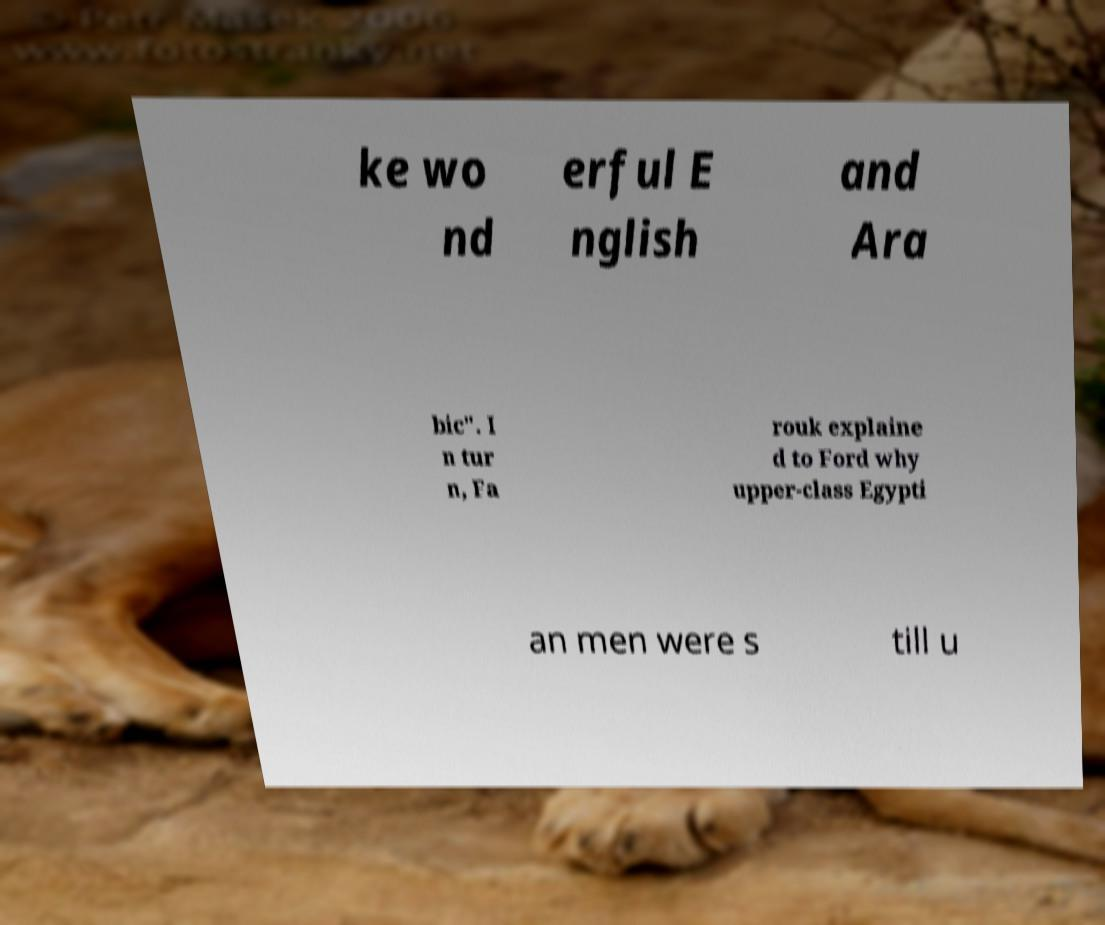For documentation purposes, I need the text within this image transcribed. Could you provide that? ke wo nd erful E nglish and Ara bic". I n tur n, Fa rouk explaine d to Ford why upper-class Egypti an men were s till u 